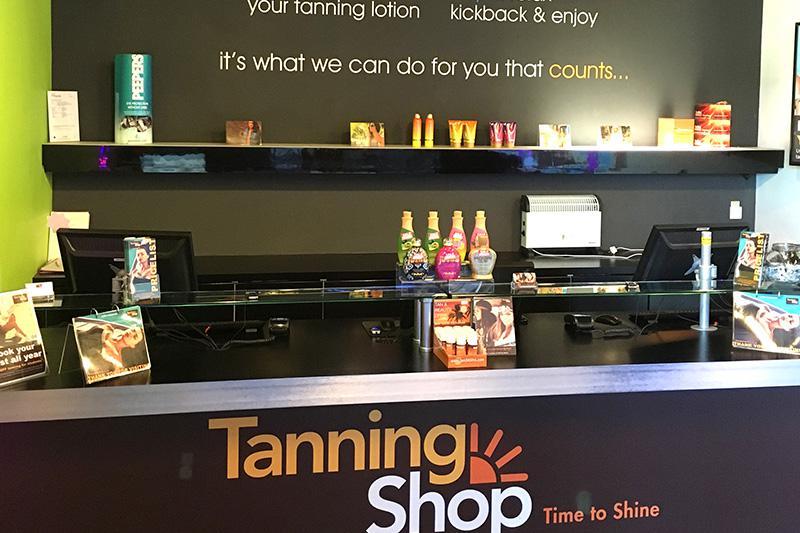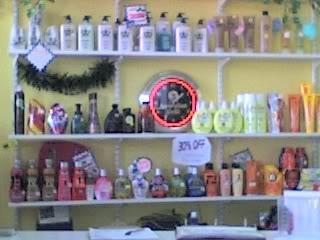The first image is the image on the left, the second image is the image on the right. Given the left and right images, does the statement "Many different kinds of tanning lotion hang behind a booth that reads Tanning Shop." hold true? Answer yes or no. Yes. The first image is the image on the left, the second image is the image on the right. For the images displayed, is the sentence "Below the salable items, you'll notice the words, """"Tanning Shop""""" factually correct? Answer yes or no. Yes. 